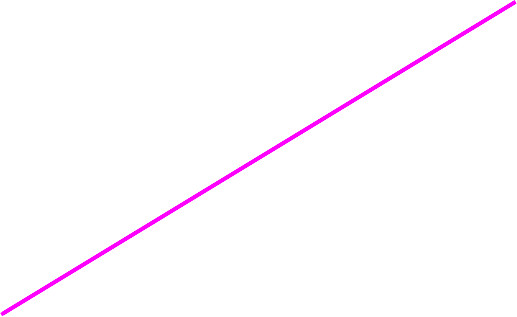Convert chart to OTSL. <chart><loc_0><loc_0><loc_500><loc_500><pie_chart><fcel>Increase (decrease) in the<nl><fcel>100.0%<nl></chart> 